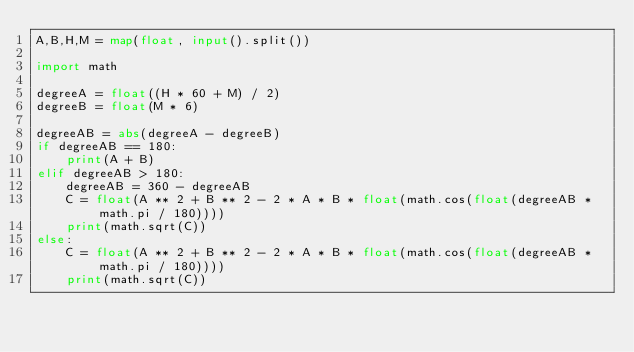Convert code to text. <code><loc_0><loc_0><loc_500><loc_500><_Python_>A,B,H,M = map(float, input().split())
 
import math
 
degreeA = float((H * 60 + M) / 2)
degreeB = float(M * 6)
 
degreeAB = abs(degreeA - degreeB)
if degreeAB == 180:
    print(A + B)
elif degreeAB > 180:
    degreeAB = 360 - degreeAB
    C = float(A ** 2 + B ** 2 - 2 * A * B * float(math.cos(float(degreeAB * math.pi / 180))))
    print(math.sqrt(C))
else:
    C = float(A ** 2 + B ** 2 - 2 * A * B * float(math.cos(float(degreeAB * math.pi / 180))))
    print(math.sqrt(C))</code> 